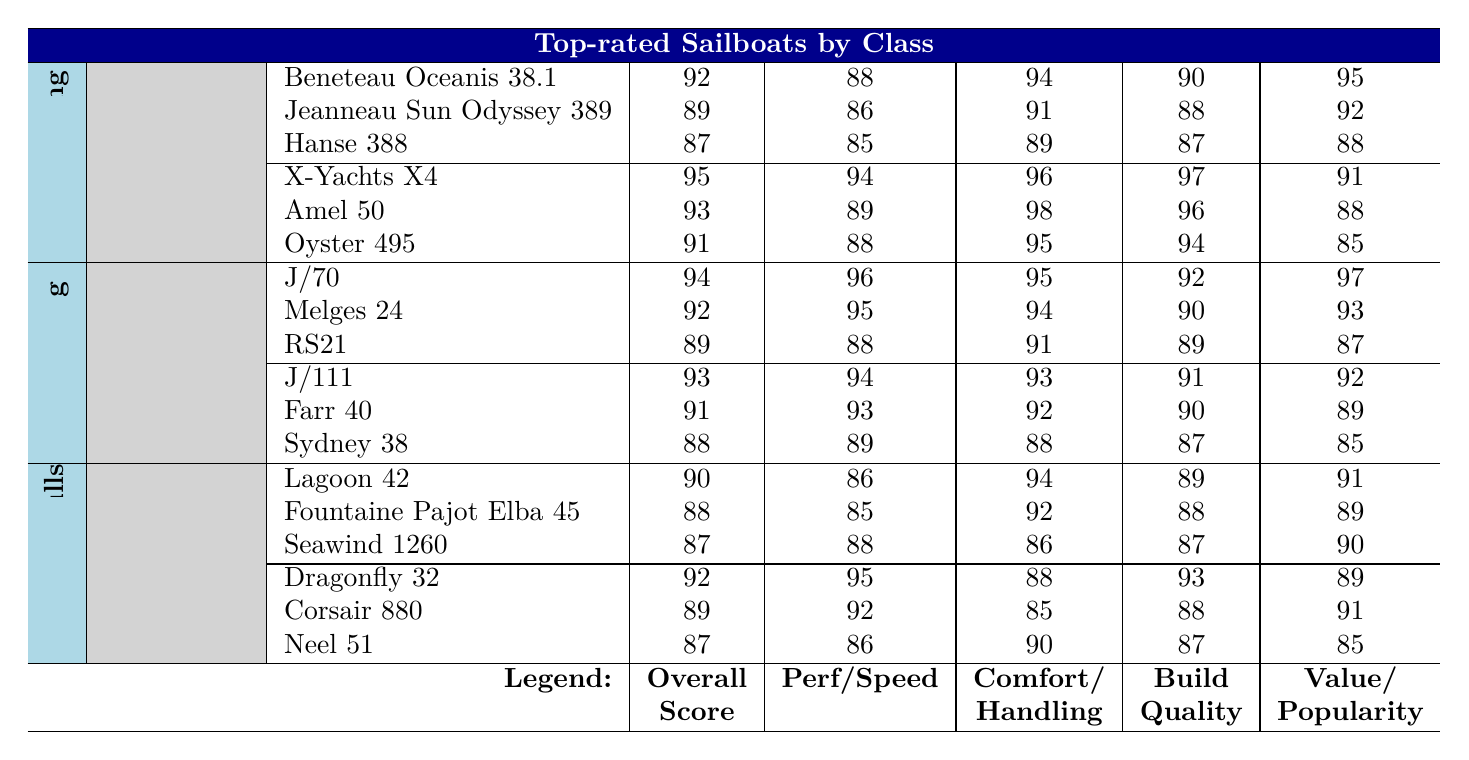What is the highest overall score among cruising sailboats in the 30-40 ft category? The highest overall score in the 30-40 ft category belongs to the Beneteau Oceanis 38.1, which has a score of 92.
Answer: 92 Which racing sailboat under 30 ft has the best speed rating? The J/70 is the top racing sailboat in the under 30 ft category with a speed rating of 96.
Answer: 96 Is the build quality of the Oyster 495 better than that of the Amel 50? The build quality of the Oyster 495 is 94, while the Amel 50 has a build quality of 96. Therefore, the Amel 50 has better build quality.
Answer: No What is the average comfort score for racing sailboats in the 30-40 ft category? The comfort scores for the three racing sailboats in this category are 93, 92, and 88. The average is calculated as (93 + 92 + 88)/3 = 91.
Answer: 91 Which multihull model has the lowest overall score? The Seawind 1260 has the lowest overall score among multihulls at 87.
Answer: 87 What is the difference in value for money between the Hanse 388 and the Jeanneau Sun Odyssey 389? The value for money for the Hanse 388 is 88, and for the Jeanneau Sun Odyssey 389, it is 92. The difference is 92 - 88 = 4.
Answer: 4 Does the Dragonfly 32 have a better performance rating than the Lagoon 42? The Dragonfly 32 has a performance rating of 95, whereas the Lagoon 42 has a performance rating of 86. Thus, the Dragonfly 32 has a better performance rating.
Answer: Yes What is the total overall score for all racing sailboats under 30 ft? The total overall score is calculated by summing the scores of the J/70, Melges 24, and RS21: 94 + 92 + 89 = 275.
Answer: 275 Which sailboat has the highest comfort score in the 40-50 ft cruising category? The Amel 50 has the highest comfort score in the 40-50 ft category with a rating of 98.
Answer: 98 How many sailboats in the racing category have an overall score of 90 or higher? In the racing category, there are five boats with overall scores of 90 or higher: J/70, Melges 24, J/111, Farr 40, and J/111.
Answer: 5 